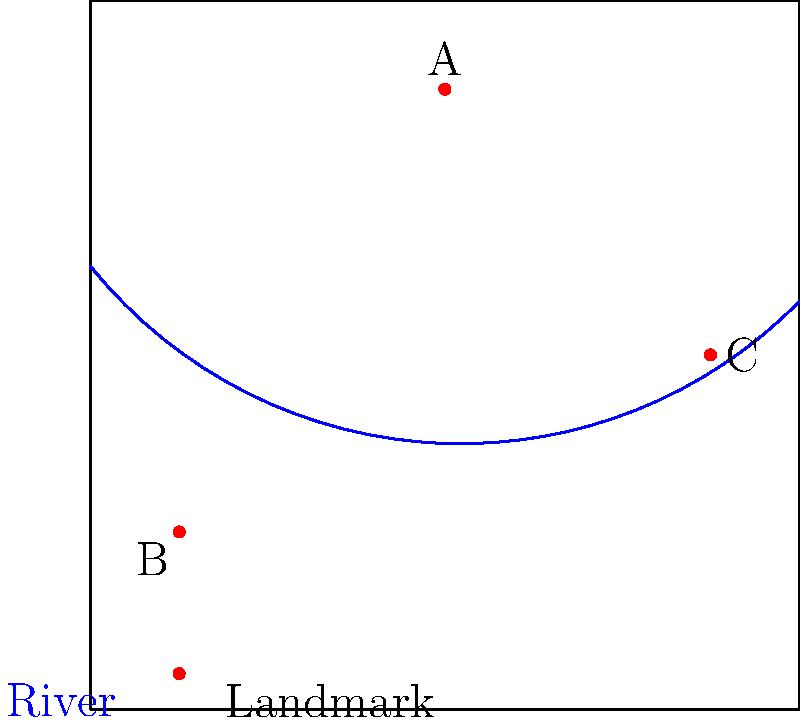Based on the simplified map of Chortkiv, which landmark is most likely to represent the Chortkiv Castle? To identify the landmark that most likely represents the Chortkiv Castle, let's analyze the map and consider the typical characteristics of castle locations:

1. Chortkiv Castle is a significant historical landmark in the city.
2. Castles are often built on high ground for defensive purposes.
3. They are typically located near water sources, such as rivers, for both defense and resource access.

Looking at the map:

1. Landmark A is located in the northern part of the city, on what appears to be higher ground (based on its position relative to the river). It's also close to the river, which bends around it.
2. Landmark B is in the southwestern part of the city, far from the river and not on apparent high ground.
3. Landmark C is in the eastern part of the city, close to the river but not on obvious high ground.

Given these observations, Landmark A is the most likely candidate for Chortkiv Castle due to its:
- Elevated position (suggesting high ground)
- Proximity to the river (for defense and resources)
- Central and prominent location in the city

Therefore, Landmark A is the most probable location for Chortkiv Castle on this simplified map.
Answer: Landmark A 